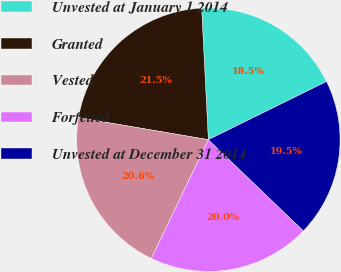Convert chart to OTSL. <chart><loc_0><loc_0><loc_500><loc_500><pie_chart><fcel>Unvested at January 1 2014<fcel>Granted<fcel>Vested<fcel>Forfeited<fcel>Unvested at December 31 2014<nl><fcel>18.53%<fcel>21.51%<fcel>20.56%<fcel>19.95%<fcel>19.45%<nl></chart> 